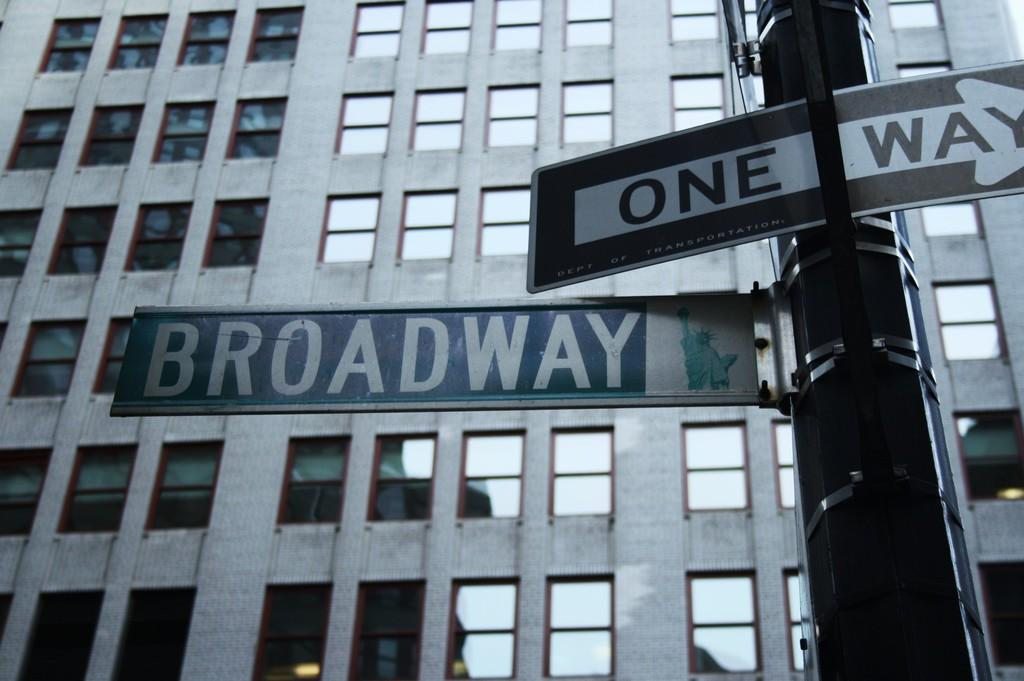What type of structure is visible in the image? There is a building in the image. What feature can be observed on the building? The building has glass windows. What is located on the right side of the image? There is a direction sign board pole on the right side of the image. What type of zinc is present in the image? There is no zinc present in the image. How many bits can be seen on the building? There are no bits visible in the image. 